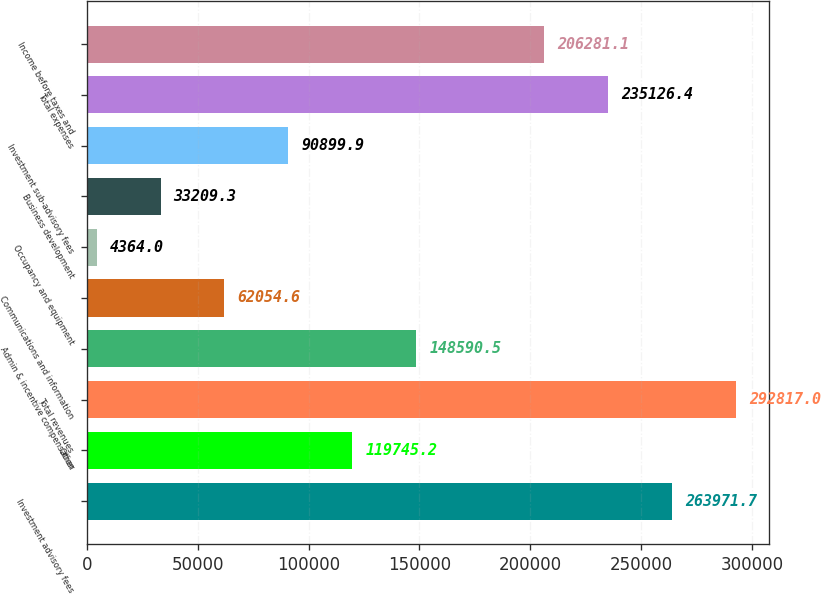Convert chart to OTSL. <chart><loc_0><loc_0><loc_500><loc_500><bar_chart><fcel>Investment advisory fees<fcel>Other<fcel>Total revenues<fcel>Admin & incentive compensation<fcel>Communications and information<fcel>Occupancy and equipment<fcel>Business development<fcel>Investment sub-advisory fees<fcel>Total expenses<fcel>Income before taxes and<nl><fcel>263972<fcel>119745<fcel>292817<fcel>148590<fcel>62054.6<fcel>4364<fcel>33209.3<fcel>90899.9<fcel>235126<fcel>206281<nl></chart> 